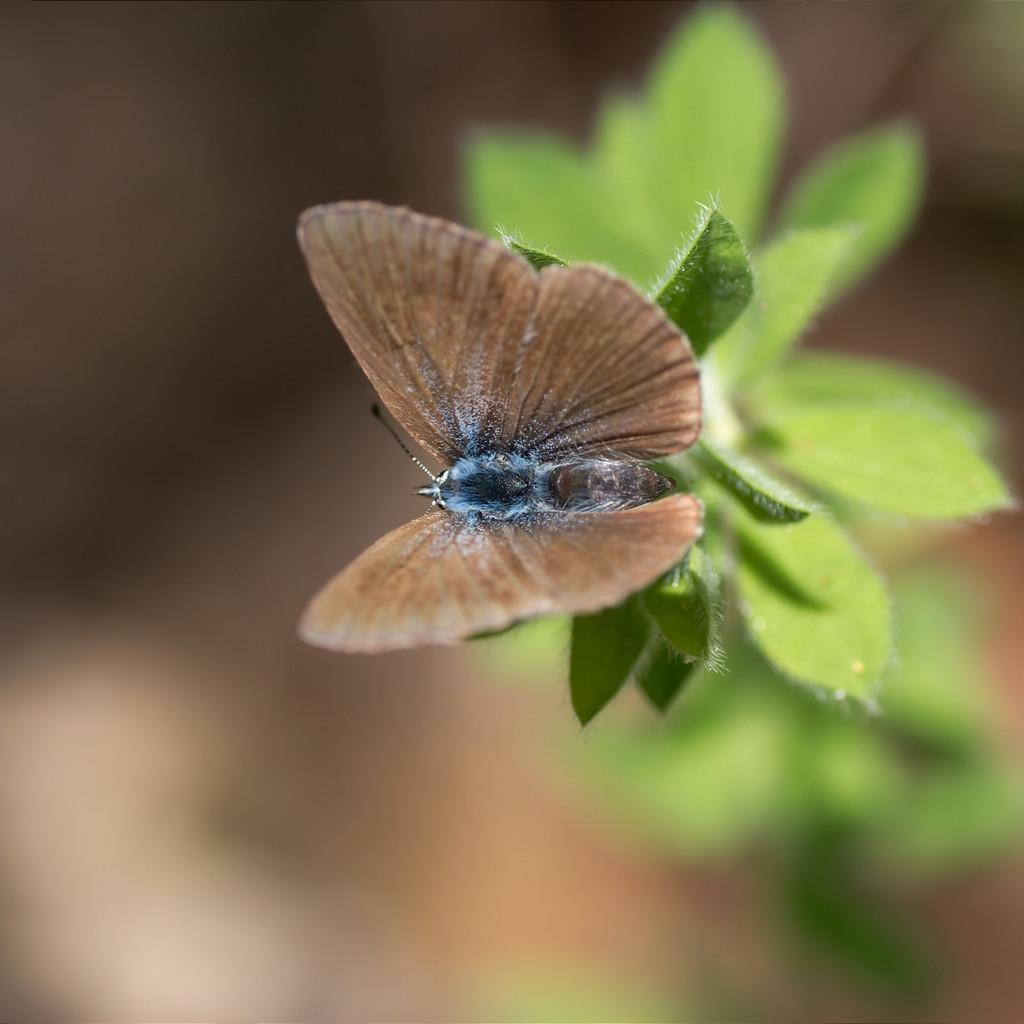What is the main subject of the image? There is a butterfly in the image. Where is the butterfly located? The butterfly is on a plant. Can you describe the plant in the image? The plant has leaves. What color are the butterfly's wings? The butterfly has brown-colored wings. How would you describe the background of the image? The background of the image is blurry. What type of locket is hanging from the tree in the image? There is no locket or tree present in the image; it features a butterfly on a plant with a blurry background. Can you tell me how many crackers are visible in the image? There are no crackers present in the image; it features a butterfly on a plant with a blurry background. 